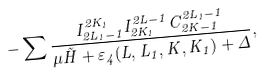Convert formula to latex. <formula><loc_0><loc_0><loc_500><loc_500>- \sum \frac { I ^ { 2 K _ { 1 } } _ { 2 L _ { 1 } - 1 } I ^ { 2 L - 1 } _ { 2 K _ { 1 } } C ^ { 2 L _ { 1 } - 1 } _ { 2 K - 1 } } { \mu \tilde { H } + \varepsilon _ { 4 } ( L , L _ { 1 } , K , K _ { 1 } ) + \Delta } ,</formula> 